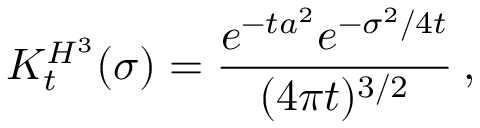<formula> <loc_0><loc_0><loc_500><loc_500>K _ { t } ^ { H ^ { 3 } } ( \sigma ) = \frac { e ^ { - t a ^ { 2 } } e ^ { - \sigma ^ { 2 } / 4 t } } { ( 4 \pi t ) ^ { 3 / 2 } } \, ,</formula> 